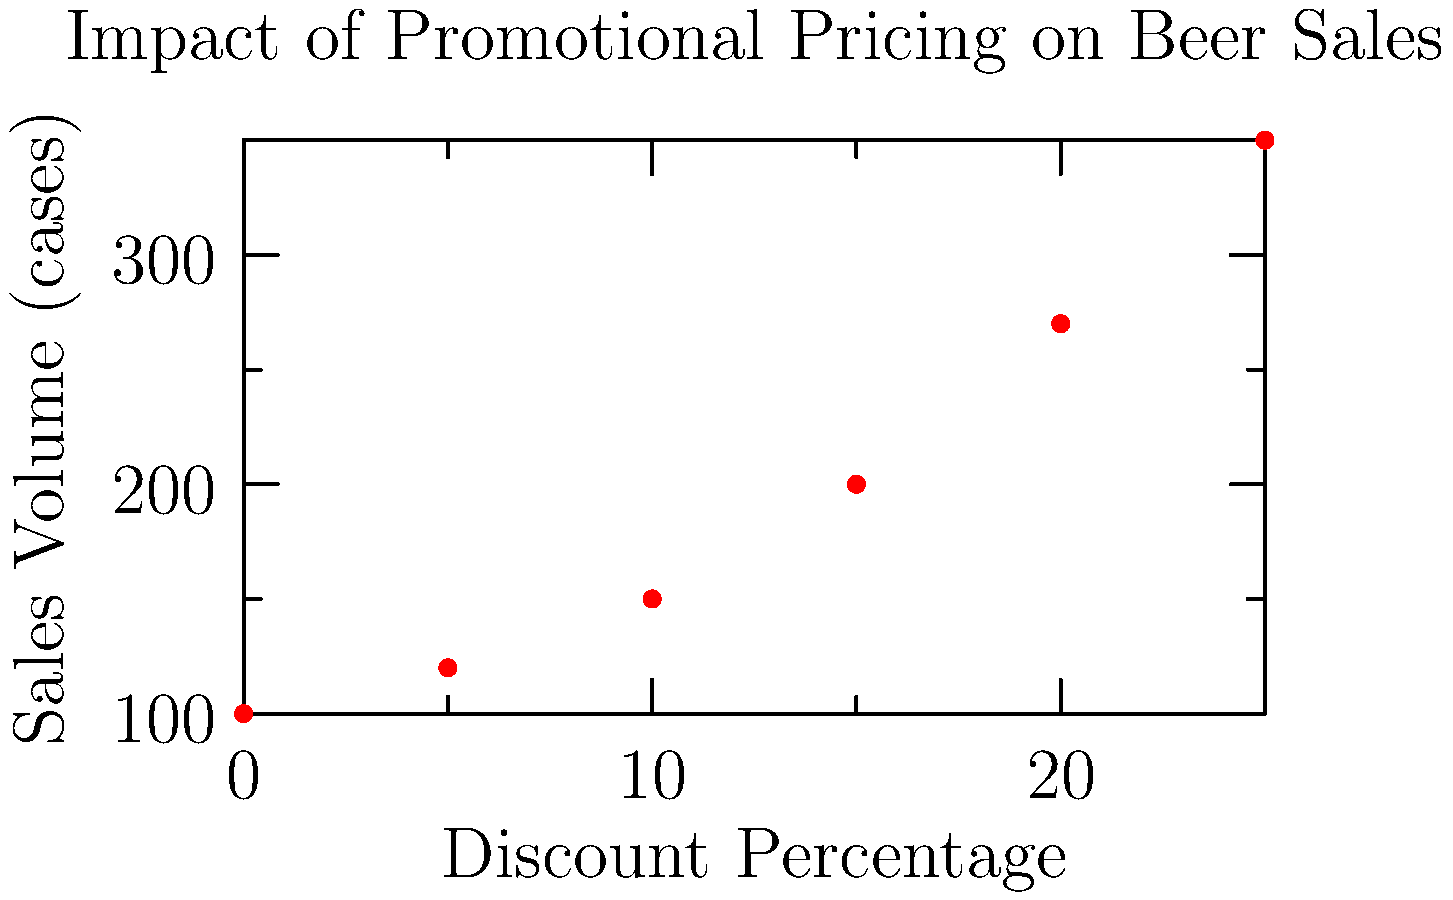Based on the scatter plot showing the relationship between discount percentage and sales volume for beer, estimate the percentage increase in sales volume when the discount is increased from 10% to 20%. To solve this problem, we need to follow these steps:

1. Identify the sales volume at 10% discount:
   At 10% discount, the sales volume is approximately 150 cases.

2. Identify the sales volume at 20% discount:
   At 20% discount, the sales volume is approximately 270 cases.

3. Calculate the increase in sales volume:
   Increase = 270 - 150 = 120 cases

4. Calculate the percentage increase:
   Percentage increase = (Increase / Original Value) * 100
   = (120 / 150) * 100 = 80%

Therefore, when the discount is increased from 10% to 20%, the sales volume increases by approximately 80%.
Answer: 80% 